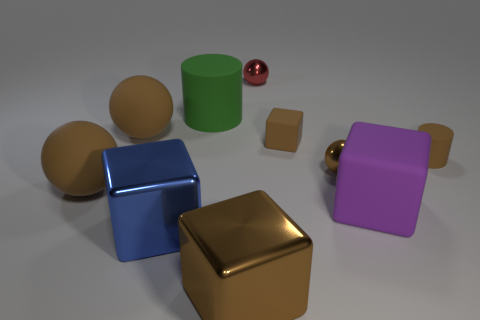What material is the large blue cube on the left side of the small rubber cylinder?
Provide a succinct answer. Metal. Is the number of balls greater than the number of big rubber blocks?
Your answer should be compact. Yes. How many things are objects that are in front of the large green cylinder or matte things?
Ensure brevity in your answer.  9. There is a big brown thing to the right of the blue block; how many large shiny cubes are left of it?
Make the answer very short. 1. There is a purple rubber thing in front of the big brown rubber thing in front of the brown cube that is behind the big brown shiny object; how big is it?
Your answer should be compact. Large. There is a small rubber object to the right of the small rubber cube; does it have the same color as the tiny matte cube?
Your response must be concise. Yes. What is the size of the brown matte object that is the same shape as the large blue metallic thing?
Your response must be concise. Small. How many things are tiny metallic balls right of the tiny red ball or cylinders to the left of the tiny cylinder?
Your answer should be very brief. 2. What is the shape of the large matte thing that is to the right of the brown block left of the red ball?
Your answer should be very brief. Cube. Are there any other things that have the same color as the tiny rubber cylinder?
Provide a succinct answer. Yes. 